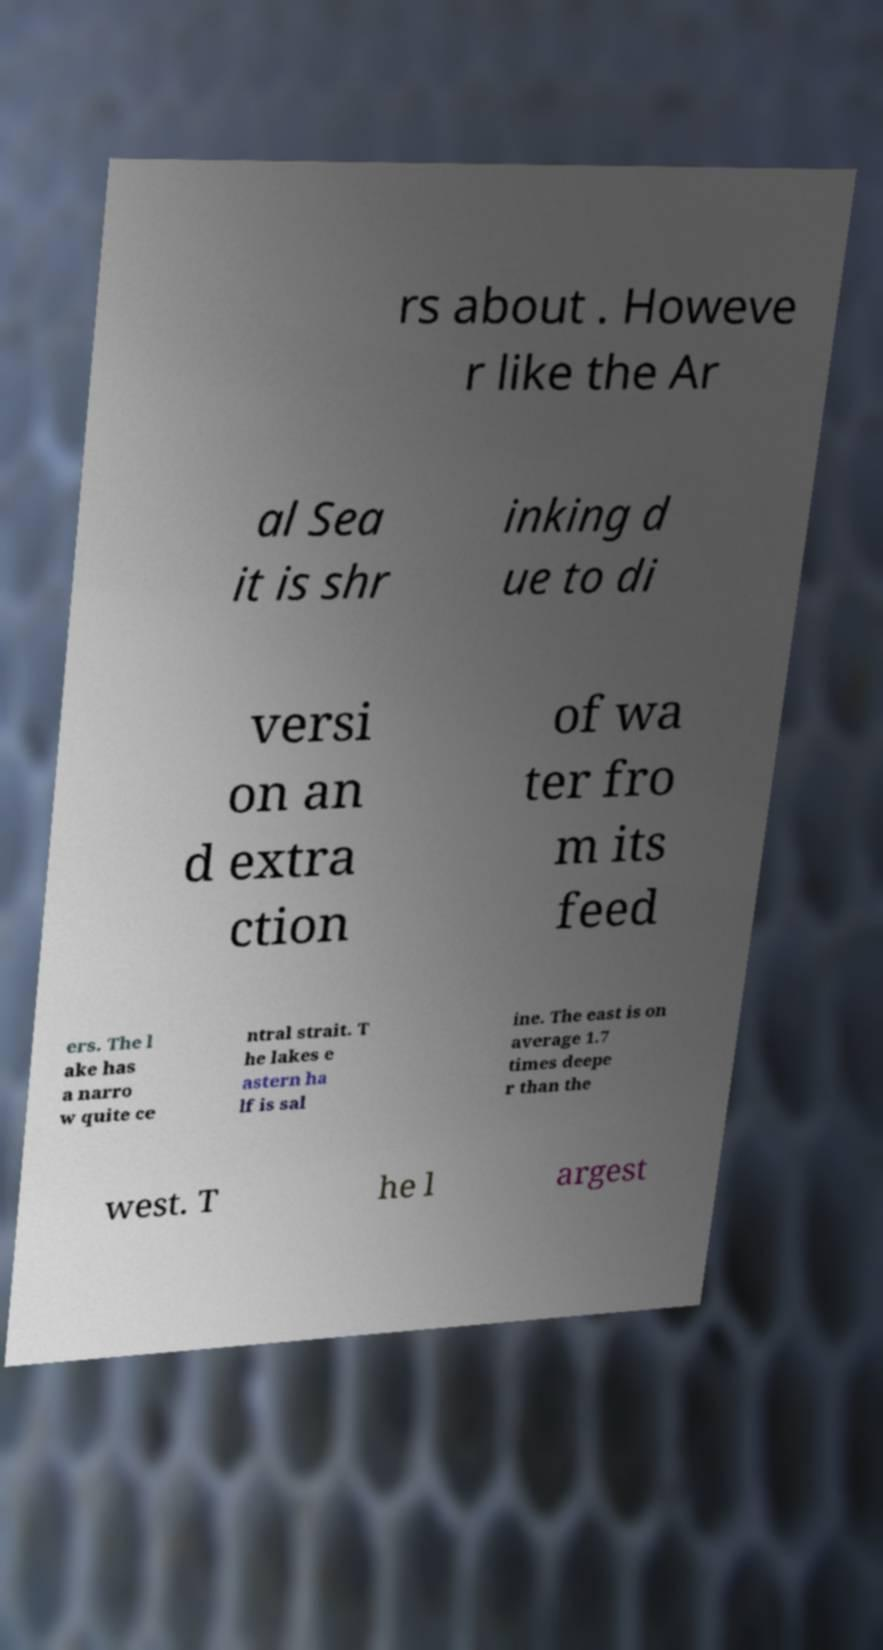Please read and relay the text visible in this image. What does it say? rs about . Howeve r like the Ar al Sea it is shr inking d ue to di versi on an d extra ction of wa ter fro m its feed ers. The l ake has a narro w quite ce ntral strait. T he lakes e astern ha lf is sal ine. The east is on average 1.7 times deepe r than the west. T he l argest 